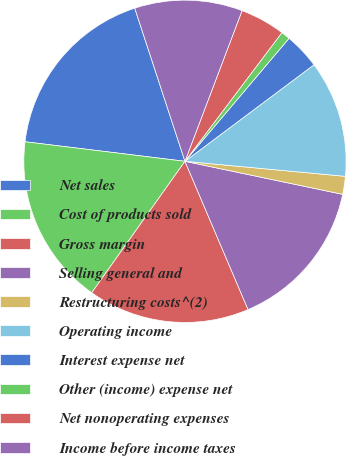<chart> <loc_0><loc_0><loc_500><loc_500><pie_chart><fcel>Net sales<fcel>Cost of products sold<fcel>Gross margin<fcel>Selling general and<fcel>Restructuring costs^(2)<fcel>Operating income<fcel>Interest expense net<fcel>Other (income) expense net<fcel>Net nonoperating expenses<fcel>Income before income taxes<nl><fcel>18.02%<fcel>17.12%<fcel>16.22%<fcel>15.31%<fcel>1.8%<fcel>11.71%<fcel>3.6%<fcel>0.9%<fcel>4.51%<fcel>10.81%<nl></chart> 